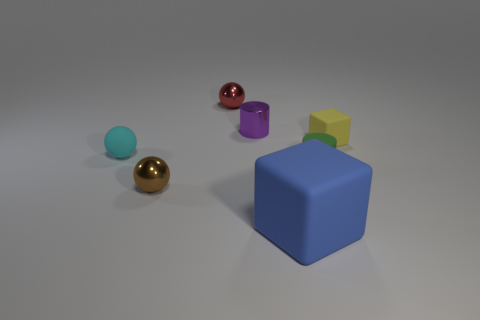Is the number of tiny yellow matte cubes greater than the number of small yellow matte cylinders?
Provide a succinct answer. Yes. How big is the brown sphere?
Your answer should be very brief. Small. How many other objects are the same color as the small rubber block?
Your answer should be very brief. 0. Is the cylinder that is to the right of the large blue block made of the same material as the red ball?
Your answer should be compact. No. Is the number of green cylinders that are to the right of the large blue block less than the number of yellow rubber blocks behind the small purple metallic thing?
Give a very brief answer. No. What number of other objects are there of the same material as the brown thing?
Keep it short and to the point. 2. What is the material of the cyan sphere that is the same size as the purple object?
Your response must be concise. Rubber. Are there fewer cyan matte objects that are in front of the brown thing than big yellow objects?
Your answer should be very brief. No. There is a tiny rubber object that is to the left of the metal sphere that is to the right of the small shiny sphere that is in front of the yellow object; what is its shape?
Offer a terse response. Sphere. What is the size of the block to the left of the small yellow thing?
Give a very brief answer. Large. 